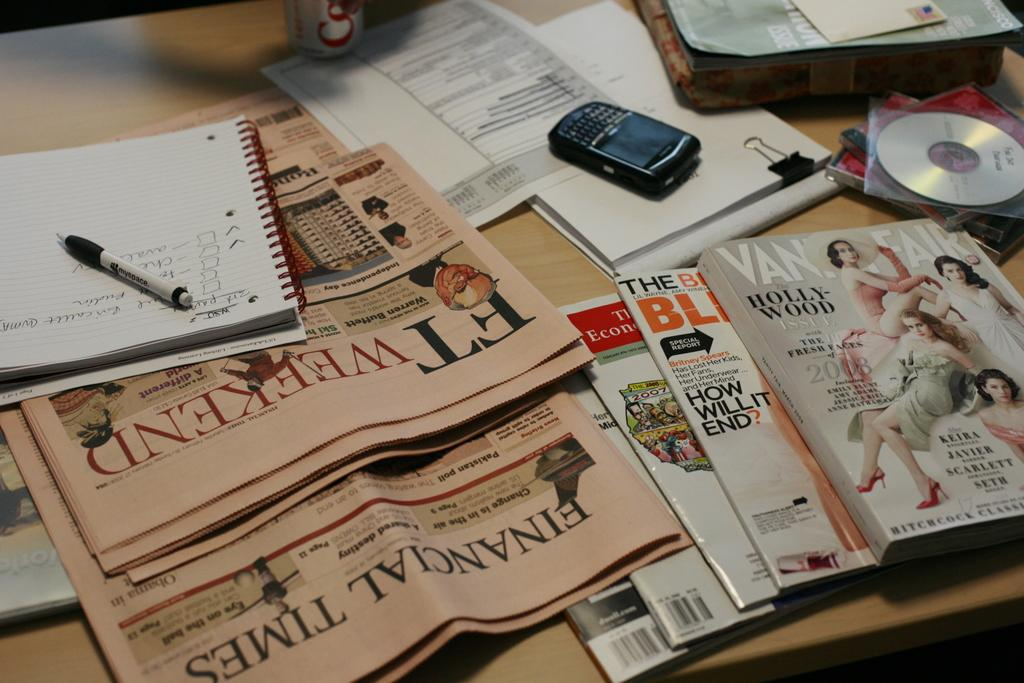<image>
Describe the image concisely. A vanity Fair magazine sits atop a stack of other magazines and newspapers. 